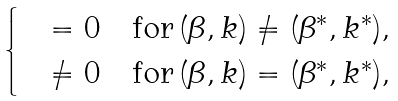Convert formula to latex. <formula><loc_0><loc_0><loc_500><loc_500>\begin{cases} & = 0 \quad \text {for} \, ( \beta , k ) \ne ( \beta ^ { * } , k ^ { * } ) , \\ & \ne 0 \quad \text {for} \, ( \beta , k ) = ( \beta ^ { * } , k ^ { * } ) , \end{cases}</formula> 